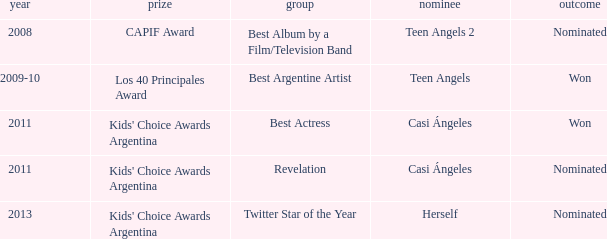For what award was there a nomination for Best Actress? Kids' Choice Awards Argentina. Could you help me parse every detail presented in this table? {'header': ['year', 'prize', 'group', 'nominee', 'outcome'], 'rows': [['2008', 'CAPIF Award', 'Best Album by a Film/Television Band', 'Teen Angels 2', 'Nominated'], ['2009-10', 'Los 40 Principales Award', 'Best Argentine Artist', 'Teen Angels', 'Won'], ['2011', "Kids' Choice Awards Argentina", 'Best Actress', 'Casi Ángeles', 'Won'], ['2011', "Kids' Choice Awards Argentina", 'Revelation', 'Casi Ángeles', 'Nominated'], ['2013', "Kids' Choice Awards Argentina", 'Twitter Star of the Year', 'Herself', 'Nominated']]} 